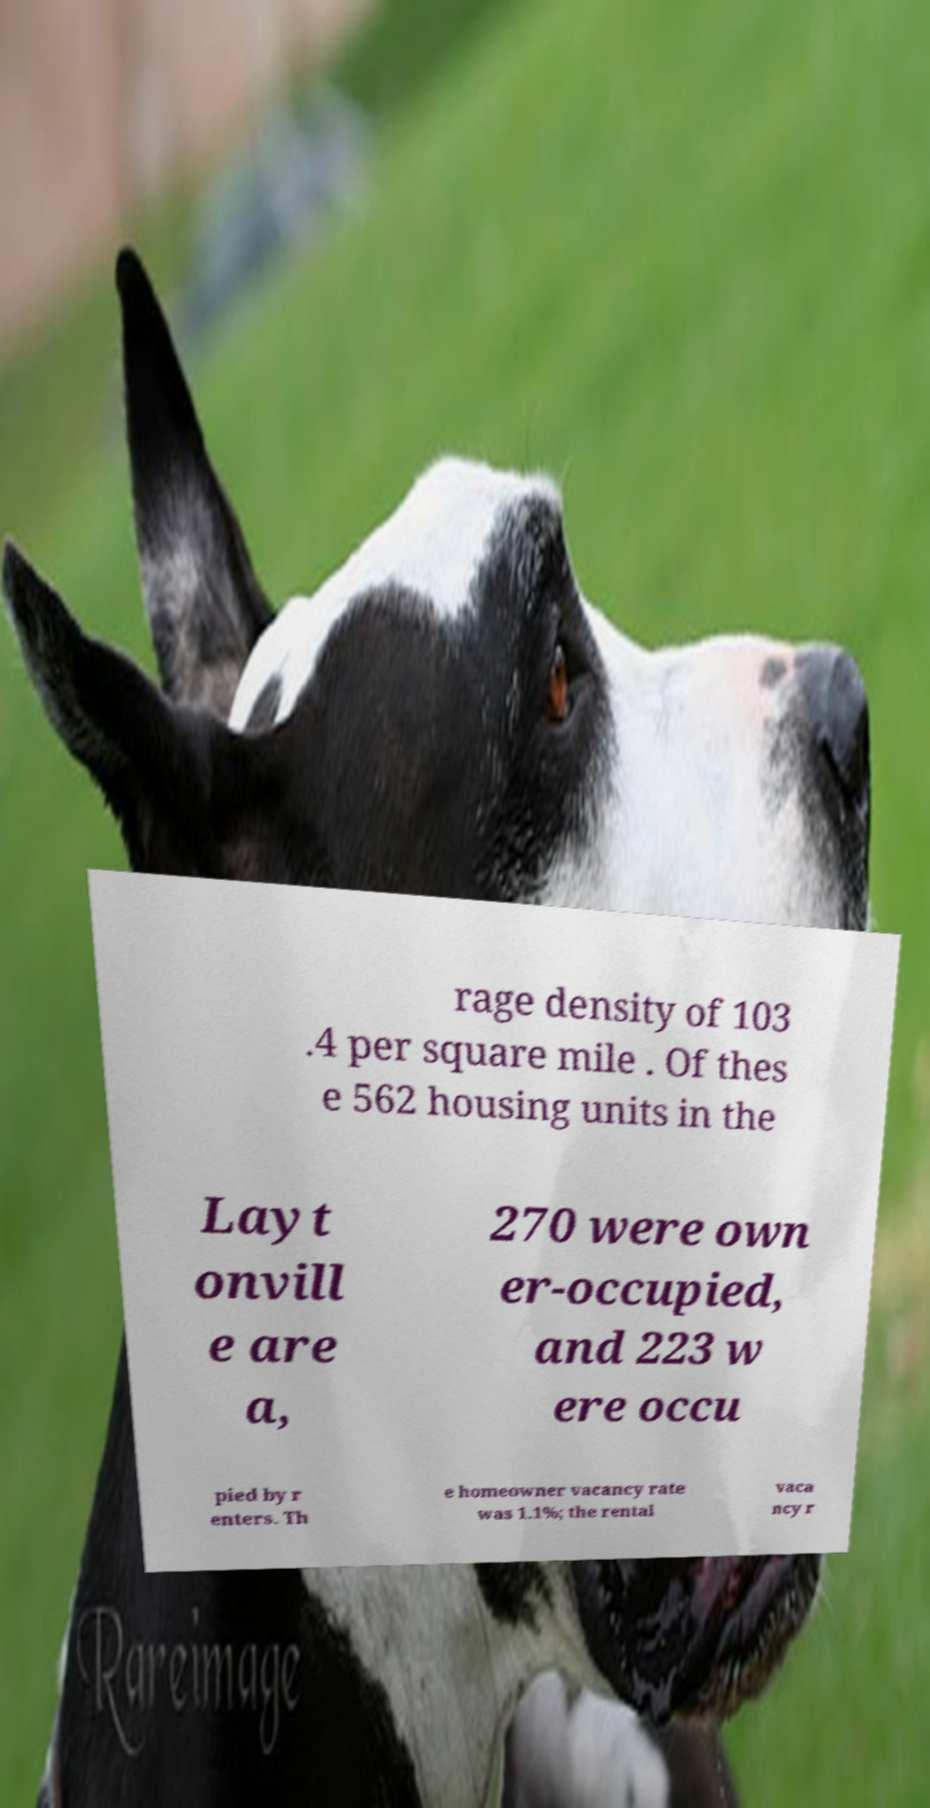Please read and relay the text visible in this image. What does it say? rage density of 103 .4 per square mile . Of thes e 562 housing units in the Layt onvill e are a, 270 were own er-occupied, and 223 w ere occu pied by r enters. Th e homeowner vacancy rate was 1.1%; the rental vaca ncy r 